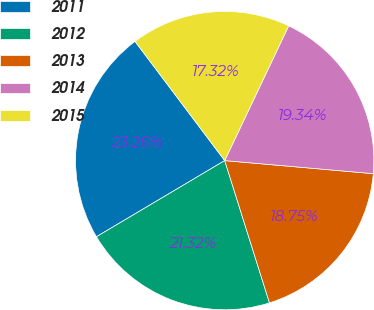Convert chart to OTSL. <chart><loc_0><loc_0><loc_500><loc_500><pie_chart><fcel>2011<fcel>2012<fcel>2013<fcel>2014<fcel>2015<nl><fcel>23.26%<fcel>21.32%<fcel>18.75%<fcel>19.34%<fcel>17.32%<nl></chart> 